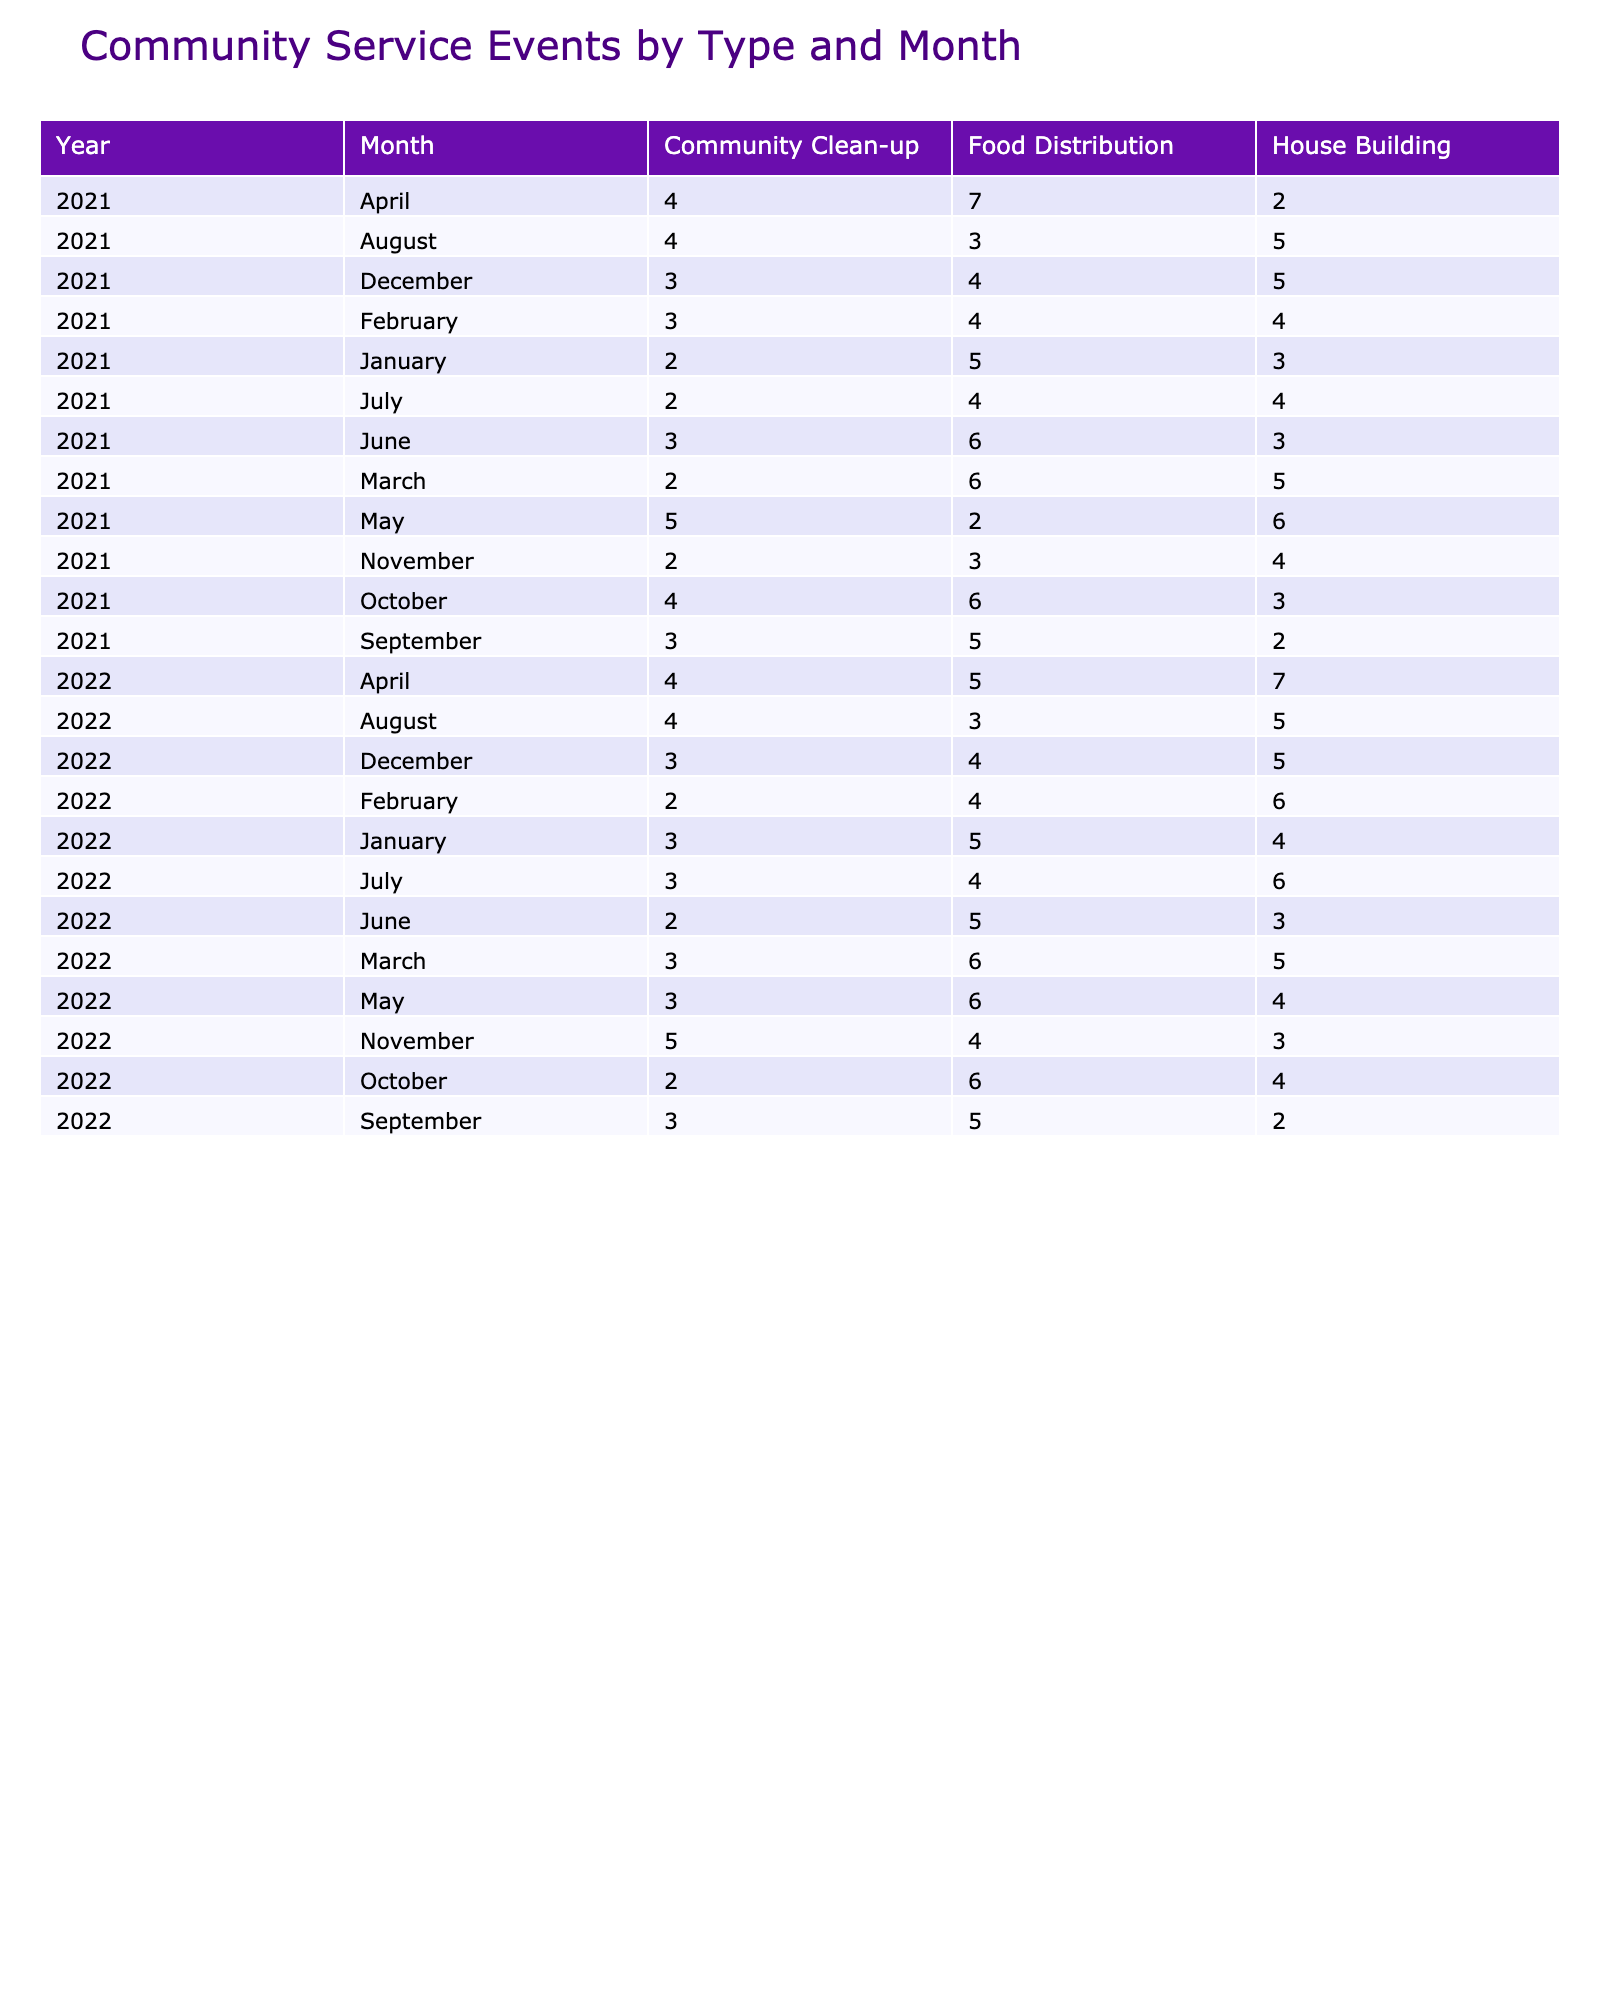What is the total number of House Building events held in March 2022? In March 2022, the number of House Building events is noted as 5 in the table. Since there are no other entries for House Building in that month, the total remains 5.
Answer: 5 How many Food Distribution events were held in June 2021? Looking at June 2021 in the table, the number of Food Distribution events is recorded as 6. There are no other categories mixed in that month for food distribution, so the count is directly taken from the table.
Answer: 6 Which month had the highest number of Community Clean-up events in 2021? By examining the table for Community Clean-up events in 2021, we find that the highest count is 5 in May 2021. We compare the counts for May, April, January, etc., and confirm that May tops the list with 5.
Answer: May 2021 Did the number of House Building events increase from 2021 to 2022 in January? In January 2021, there were 3 House Building events, and in January 2022, this increased to 4 events. Since 4 is greater than 3, we conclude that there was an increase in House Building events.
Answer: Yes What is the average number of Food Distribution events across all months in 2022? We need to sum the Food Distribution events for all months in 2022: 5 (January) + 4 (February) + 6 (March) + 5 (April) + 6 (May) + 5 (June) + 4 (July) + 3 (August) + 5 (September) + 6 (October) + 4 (November) + 4 (December) = 58. There are 12 months, so the average is 58/12 ≈ 4.83.
Answer: 4.83 How many events were held in total across all types of service in December 2021? In December 2021, the counts for events are House Building (5), Food Distribution (4), and Community Clean-up (3). We sum these numbers: 5 + 4 + 3 = 12. Therefore, the total number of events for December 2021 is 12.
Answer: 12 Which type of service had the lowest number of events in February 2021? In February 2021, there were 4 House Building, 4 Food Distribution, and 3 Community Clean-up events. The lowest count is for Community Clean-up with 3 events. We identify the lowest among the three counts.
Answer: Community Clean-up What is the difference in the number of House Building events between April 2021 and April 2022? In April 2021, there were 2 House Building events, while in April 2022, there were 7 events. The difference is calculated as: 7 - 2 = 5. This indicates that there were 5 more House Building events in April 2022 compared to April 2021.
Answer: 5 